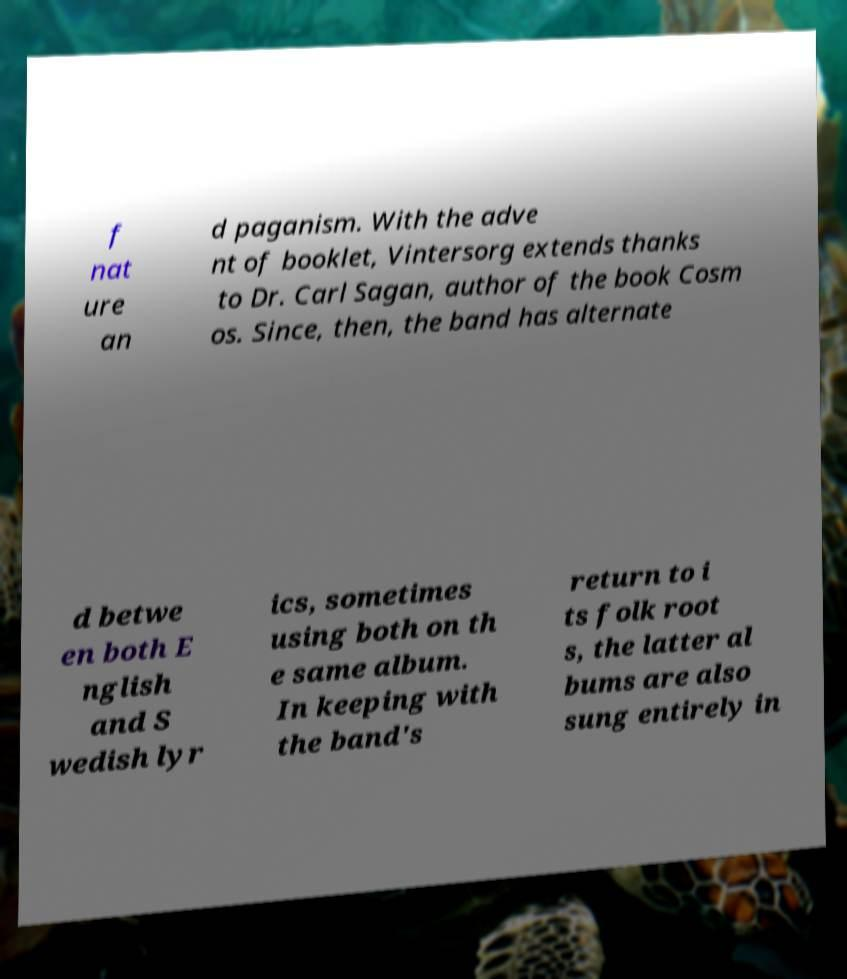What messages or text are displayed in this image? I need them in a readable, typed format. f nat ure an d paganism. With the adve nt of booklet, Vintersorg extends thanks to Dr. Carl Sagan, author of the book Cosm os. Since, then, the band has alternate d betwe en both E nglish and S wedish lyr ics, sometimes using both on th e same album. In keeping with the band's return to i ts folk root s, the latter al bums are also sung entirely in 